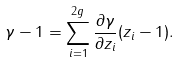<formula> <loc_0><loc_0><loc_500><loc_500>\gamma - 1 = \sum _ { i = 1 } ^ { 2 g } \frac { \partial \gamma } { \partial z _ { i } } ( z _ { i } - 1 ) .</formula> 